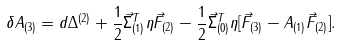<formula> <loc_0><loc_0><loc_500><loc_500>\delta A _ { ( 3 ) } = d \Delta ^ { ( 2 ) } + \frac { 1 } { 2 } \vec { \Sigma } _ { ( 1 ) } ^ { T } \eta \vec { F } _ { ( 2 ) } - \frac { 1 } { 2 } \vec { \Sigma } _ { ( 0 ) } ^ { T } \eta [ \vec { F } _ { ( 3 ) } - A _ { ( 1 ) } \vec { F } _ { ( 2 ) } ] .</formula> 